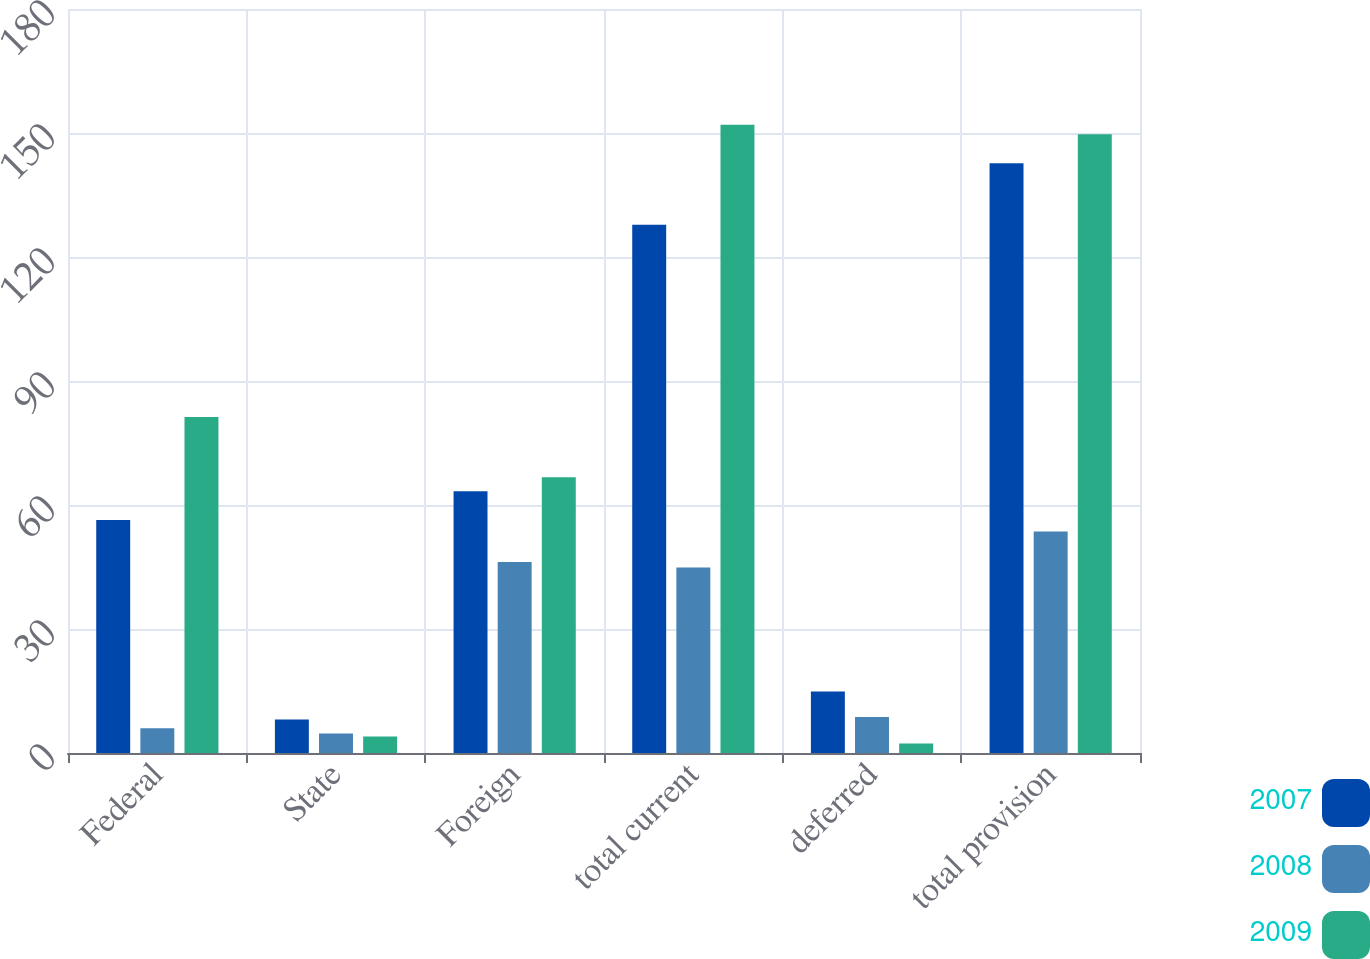Convert chart to OTSL. <chart><loc_0><loc_0><loc_500><loc_500><stacked_bar_chart><ecel><fcel>Federal<fcel>State<fcel>Foreign<fcel>total current<fcel>deferred<fcel>total provision<nl><fcel>2007<fcel>56.4<fcel>8.1<fcel>63.3<fcel>127.8<fcel>14.9<fcel>142.7<nl><fcel>2008<fcel>6<fcel>4.7<fcel>46.2<fcel>44.9<fcel>8.7<fcel>53.6<nl><fcel>2009<fcel>81.3<fcel>4<fcel>66.7<fcel>152<fcel>2.3<fcel>149.7<nl></chart> 